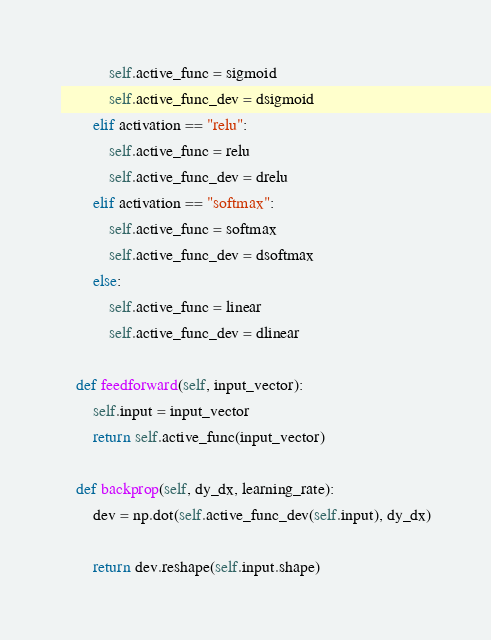Convert code to text. <code><loc_0><loc_0><loc_500><loc_500><_Python_>            self.active_func = sigmoid
            self.active_func_dev = dsigmoid
        elif activation == "relu":
            self.active_func = relu
            self.active_func_dev = drelu
        elif activation == "softmax":
            self.active_func = softmax
            self.active_func_dev = dsoftmax
        else:
            self.active_func = linear
            self.active_func_dev = dlinear

    def feedforward(self, input_vector):
        self.input = input_vector
        return self.active_func(input_vector)

    def backprop(self, dy_dx, learning_rate):
        dev = np.dot(self.active_func_dev(self.input), dy_dx)

        return dev.reshape(self.input.shape)
</code> 